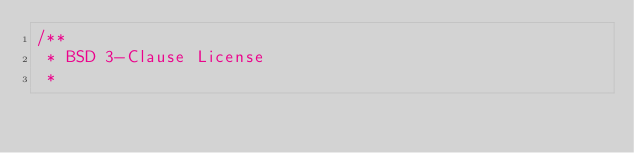<code> <loc_0><loc_0><loc_500><loc_500><_C++_>/**
 * BSD 3-Clause License
 *</code> 